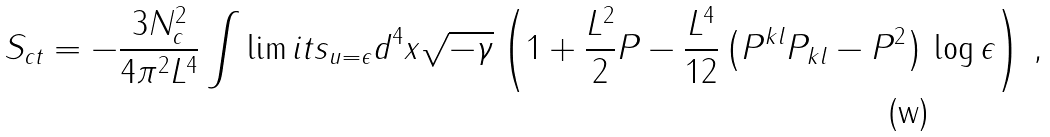Convert formula to latex. <formula><loc_0><loc_0><loc_500><loc_500>S _ { c t } = - \frac { 3 N _ { c } ^ { 2 } } { 4 \pi ^ { 2 } L ^ { 4 } } \int \lim i t s _ { u = \epsilon } d ^ { 4 } x \sqrt { - \gamma } \left ( 1 + \frac { L ^ { 2 } } { 2 } P - \frac { L ^ { 4 } } { 1 2 } \left ( P ^ { k l } P _ { k l } - P ^ { 2 } \right ) \, \log { \epsilon } \right ) \, ,</formula> 